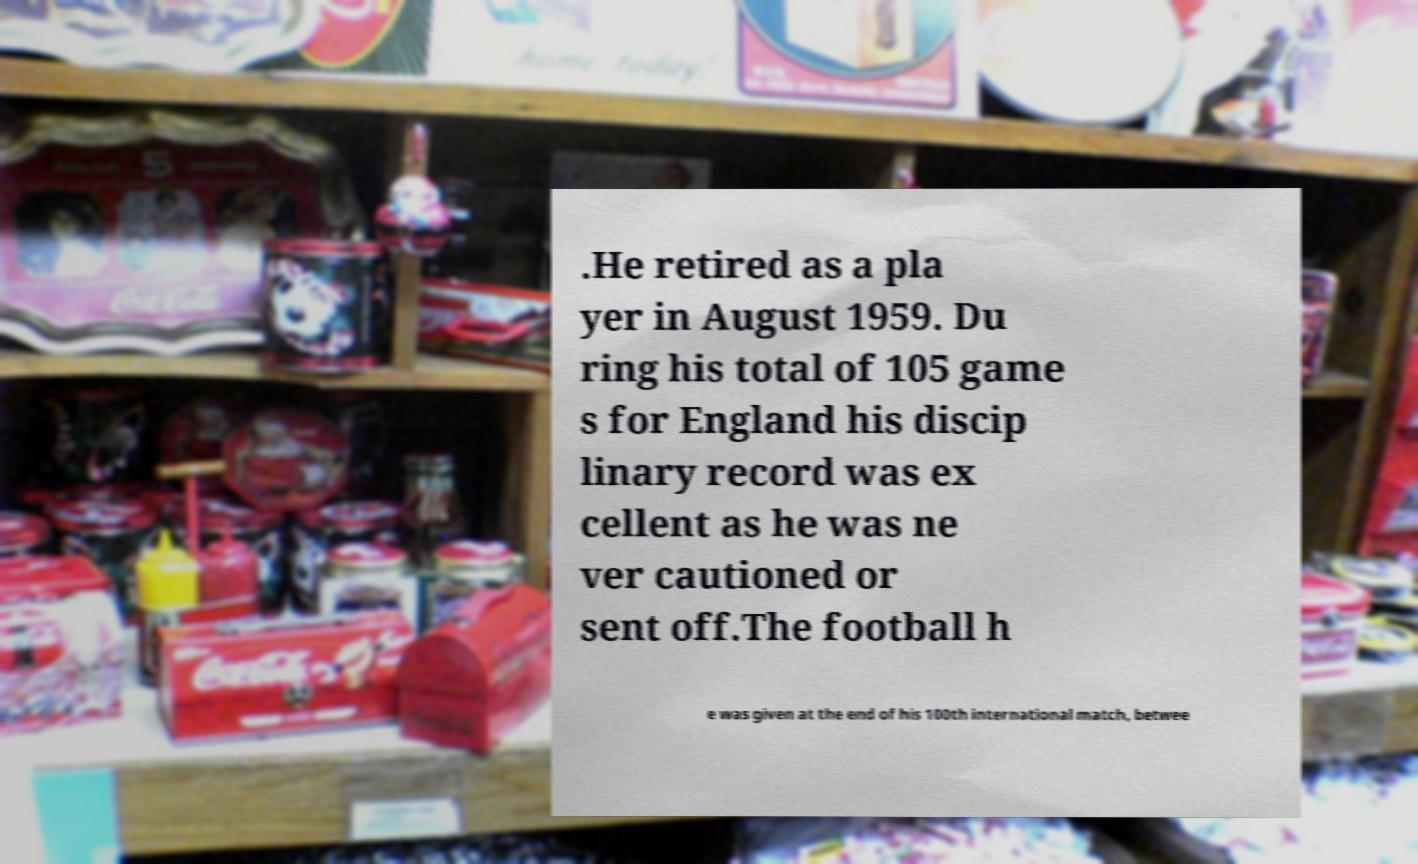For documentation purposes, I need the text within this image transcribed. Could you provide that? .He retired as a pla yer in August 1959. Du ring his total of 105 game s for England his discip linary record was ex cellent as he was ne ver cautioned or sent off.The football h e was given at the end of his 100th international match, betwee 